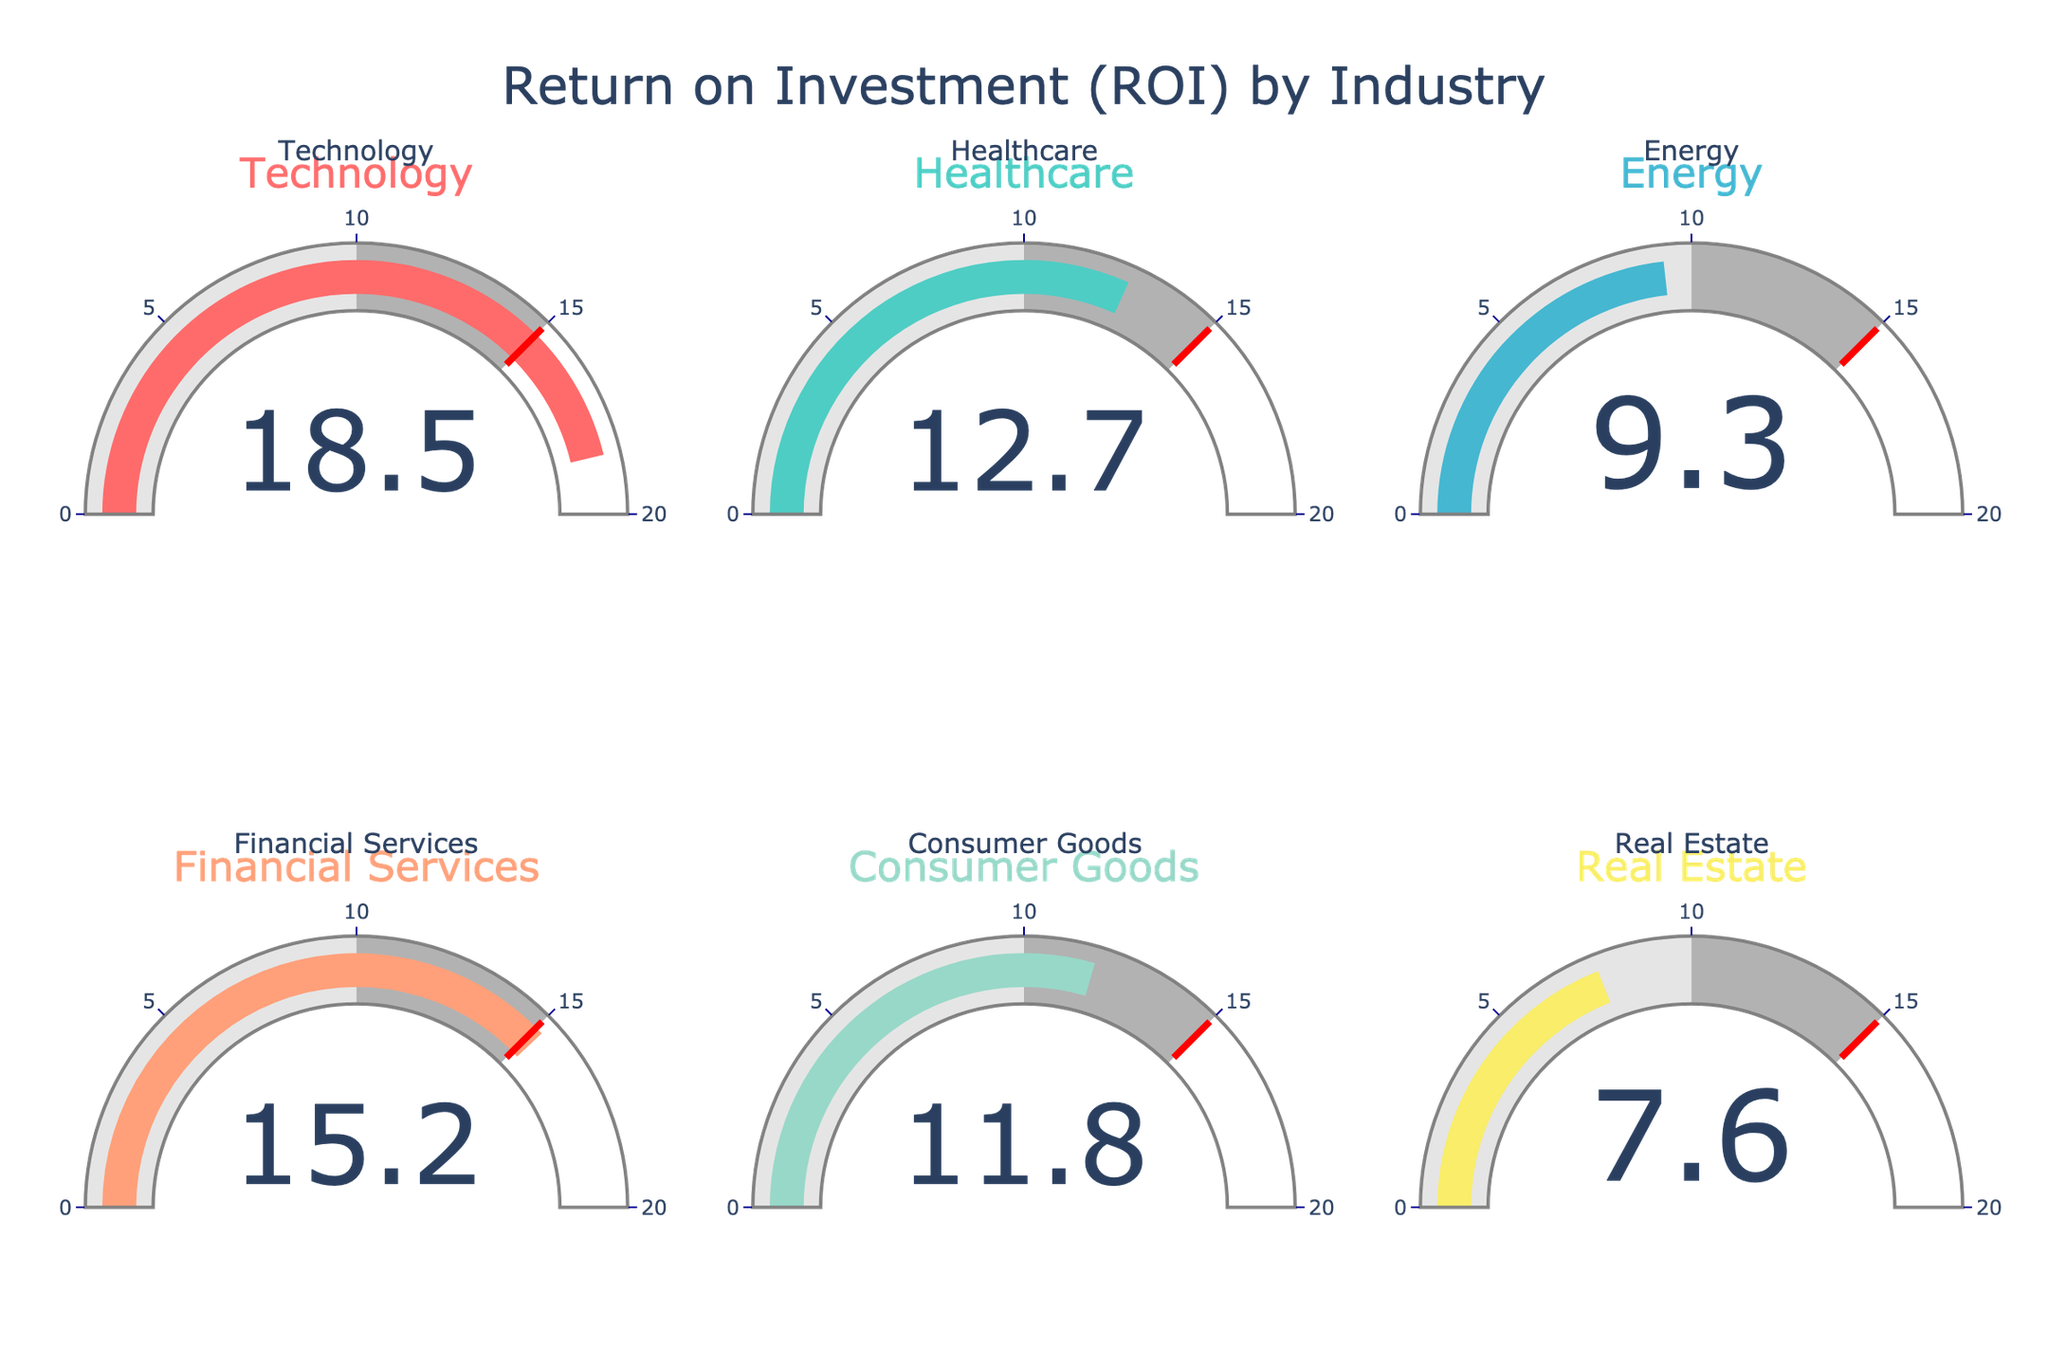What's the title of the figure? The title of the figure is displayed at the top center, reading "Return on Investment (ROI) by Industry".
Answer: Return on Investment (ROI) by Industry How many industry sectors are represented in the figure? There are six gauges in the figure, each representing a different industry sector: Technology, Healthcare, Energy, Financial Services, Consumer Goods, and Real Estate.
Answer: Six Which industry has the highest ROI? By looking at the gauge with the highest value, you can see that the Technology sector has the highest ROI at 18.5%.
Answer: Technology What's the difference in ROI between the highest and lowest industry sectors? The Technology sector has the highest ROI at 18.5%, and the Real Estate sector has the lowest ROI at 7.6%. The difference is 18.5% - 7.6% = 10.9%.
Answer: 10.9% Which industry sectors have an ROI above 15%? Two sectors have an ROI above 15%: Technology (18.5%) and Financial Services (15.2%).
Answer: Technology and Financial Services What is the average ROI of all the industry sectors represented? To find the average, sum all the ROIs and divide by the number of industries: (18.5 + 12.7 + 9.3 + 15.2 + 11.8 + 7.6) / 6 = 75.1 / 6 = 12.52%.
Answer: 12.52% How does the ROI of Healthcare compare to Consumer Goods? The Healthcare sector has an ROI of 12.7%, while Consumer Goods has an ROI of 11.8%. Comparing these, Healthcare's ROI is higher by 12.7% - 11.8% = 0.9%.
Answer: 0.9% higher What is the median ROI among all industry sectors? First, list the ROIs in ascending order: 7.6%, 9.3%, 11.8%, 12.7%, 15.2%, 18.5%. The median is the average of the middle two values: (11.8% + 12.7%) / 2 = 12.25%.
Answer: 12.25% Is there any sector with an ROI below the threshold level indicated in the gauge? The threshold line is set at 15%. The sectors with an ROI below this threshold are Healthcare, Energy, Consumer Goods, and Real Estate.
Answer: Yes How many sectors have an ROI in the range of 10% to 15%? The sectors with an ROI in the range of 10% to 15% include Healthcare (12.7%), Consumer Goods (11.8%), and Financial Services (15.2%), but since 15.2% is not strictly within the range, it should not be counted. Thus, there are 2 sectors.
Answer: Two 